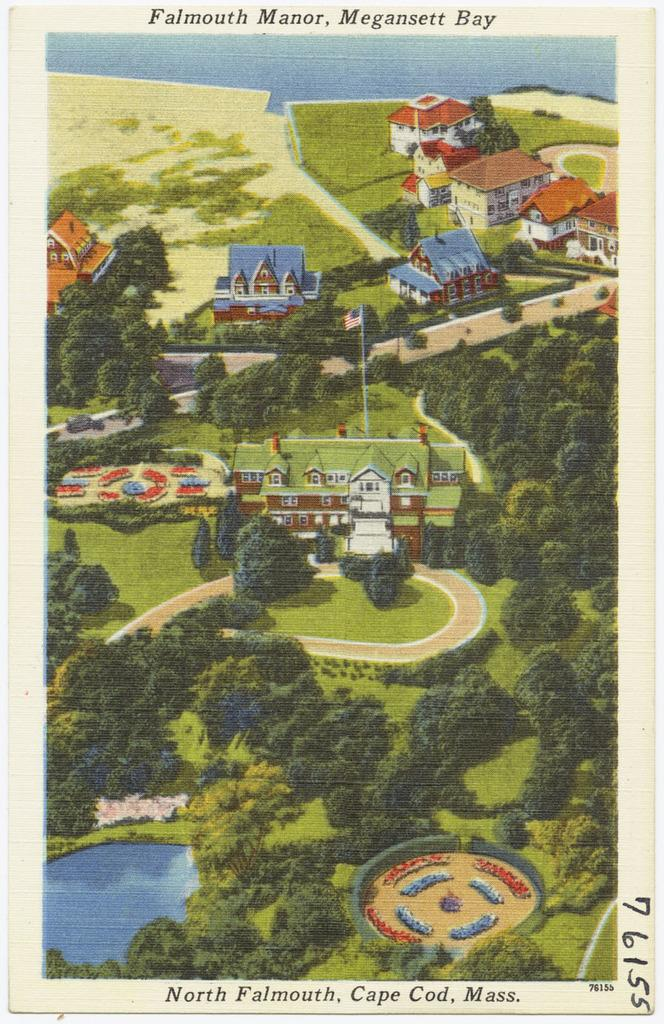Provide a one-sentence caption for the provided image. An old printed picture shows the layout an home of the Falmouth Manor. 